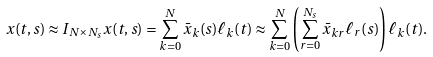Convert formula to latex. <formula><loc_0><loc_0><loc_500><loc_500>x ( t , s ) & \approx I _ { N \times N _ { s } } x ( t , s ) = \sum _ { k = 0 } ^ { N } \bar { x } _ { k } ( s ) \ell _ { k } ( t ) \approx \sum _ { k = 0 } ^ { N } \left ( \sum _ { r = 0 } ^ { N _ { s } } \bar { x } _ { k r } \ell _ { r } ( s ) \right ) \ell _ { k } ( t ) .</formula> 